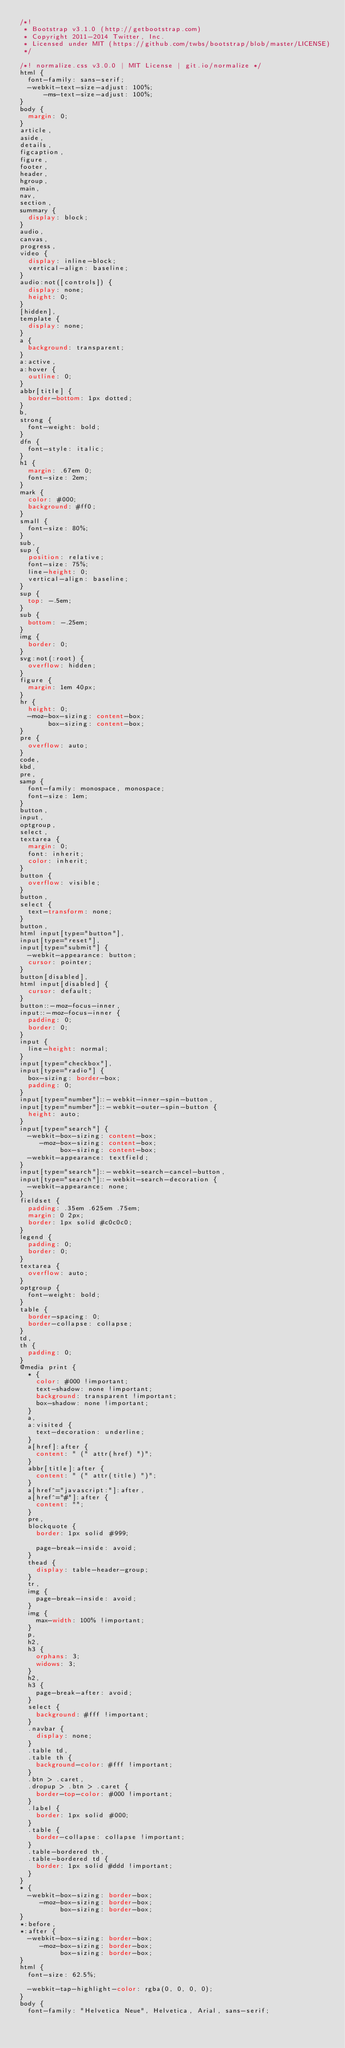<code> <loc_0><loc_0><loc_500><loc_500><_CSS_>/*!
 * Bootstrap v3.1.0 (http://getbootstrap.com)
 * Copyright 2011-2014 Twitter, Inc.
 * Licensed under MIT (https://github.com/twbs/bootstrap/blob/master/LICENSE)
 */

/*! normalize.css v3.0.0 | MIT License | git.io/normalize */
html {
  font-family: sans-serif;
  -webkit-text-size-adjust: 100%;
      -ms-text-size-adjust: 100%;
}
body {
  margin: 0;
}
article,
aside,
details,
figcaption,
figure,
footer,
header,
hgroup,
main,
nav,
section,
summary {
  display: block;
}
audio,
canvas,
progress,
video {
  display: inline-block;
  vertical-align: baseline;
}
audio:not([controls]) {
  display: none;
  height: 0;
}
[hidden],
template {
  display: none;
}
a {
  background: transparent;
}
a:active,
a:hover {
  outline: 0;
}
abbr[title] {
  border-bottom: 1px dotted;
}
b,
strong {
  font-weight: bold;
}
dfn {
  font-style: italic;
}
h1 {
  margin: .67em 0;
  font-size: 2em;
}
mark {
  color: #000;
  background: #ff0;
}
small {
  font-size: 80%;
}
sub,
sup {
  position: relative;
  font-size: 75%;
  line-height: 0;
  vertical-align: baseline;
}
sup {
  top: -.5em;
}
sub {
  bottom: -.25em;
}
img {
  border: 0;
}
svg:not(:root) {
  overflow: hidden;
}
figure {
  margin: 1em 40px;
}
hr {
  height: 0;
  -moz-box-sizing: content-box;
       box-sizing: content-box;
}
pre {
  overflow: auto;
}
code,
kbd,
pre,
samp {
  font-family: monospace, monospace;
  font-size: 1em;
}
button,
input,
optgroup,
select,
textarea {
  margin: 0;
  font: inherit;
  color: inherit;
}
button {
  overflow: visible;
}
button,
select {
  text-transform: none;
}
button,
html input[type="button"],
input[type="reset"],
input[type="submit"] {
  -webkit-appearance: button;
  cursor: pointer;
}
button[disabled],
html input[disabled] {
  cursor: default;
}
button::-moz-focus-inner,
input::-moz-focus-inner {
  padding: 0;
  border: 0;
}
input {
  line-height: normal;
}
input[type="checkbox"],
input[type="radio"] {
  box-sizing: border-box;
  padding: 0;
}
input[type="number"]::-webkit-inner-spin-button,
input[type="number"]::-webkit-outer-spin-button {
  height: auto;
}
input[type="search"] {
  -webkit-box-sizing: content-box;
     -moz-box-sizing: content-box;
          box-sizing: content-box;
  -webkit-appearance: textfield;
}
input[type="search"]::-webkit-search-cancel-button,
input[type="search"]::-webkit-search-decoration {
  -webkit-appearance: none;
}
fieldset {
  padding: .35em .625em .75em;
  margin: 0 2px;
  border: 1px solid #c0c0c0;
}
legend {
  padding: 0;
  border: 0;
}
textarea {
  overflow: auto;
}
optgroup {
  font-weight: bold;
}
table {
  border-spacing: 0;
  border-collapse: collapse;
}
td,
th {
  padding: 0;
}
@media print {
  * {
    color: #000 !important;
    text-shadow: none !important;
    background: transparent !important;
    box-shadow: none !important;
  }
  a,
  a:visited {
    text-decoration: underline;
  }
  a[href]:after {
    content: " (" attr(href) ")";
  }
  abbr[title]:after {
    content: " (" attr(title) ")";
  }
  a[href^="javascript:"]:after,
  a[href^="#"]:after {
    content: "";
  }
  pre,
  blockquote {
    border: 1px solid #999;

    page-break-inside: avoid;
  }
  thead {
    display: table-header-group;
  }
  tr,
  img {
    page-break-inside: avoid;
  }
  img {
    max-width: 100% !important;
  }
  p,
  h2,
  h3 {
    orphans: 3;
    widows: 3;
  }
  h2,
  h3 {
    page-break-after: avoid;
  }
  select {
    background: #fff !important;
  }
  .navbar {
    display: none;
  }
  .table td,
  .table th {
    background-color: #fff !important;
  }
  .btn > .caret,
  .dropup > .btn > .caret {
    border-top-color: #000 !important;
  }
  .label {
    border: 1px solid #000;
  }
  .table {
    border-collapse: collapse !important;
  }
  .table-bordered th,
  .table-bordered td {
    border: 1px solid #ddd !important;
  }
}
* {
  -webkit-box-sizing: border-box;
     -moz-box-sizing: border-box;
          box-sizing: border-box;
}
*:before,
*:after {
  -webkit-box-sizing: border-box;
     -moz-box-sizing: border-box;
          box-sizing: border-box;
}
html {
  font-size: 62.5%;

  -webkit-tap-highlight-color: rgba(0, 0, 0, 0);
}
body {
  font-family: "Helvetica Neue", Helvetica, Arial, sans-serif;</code> 